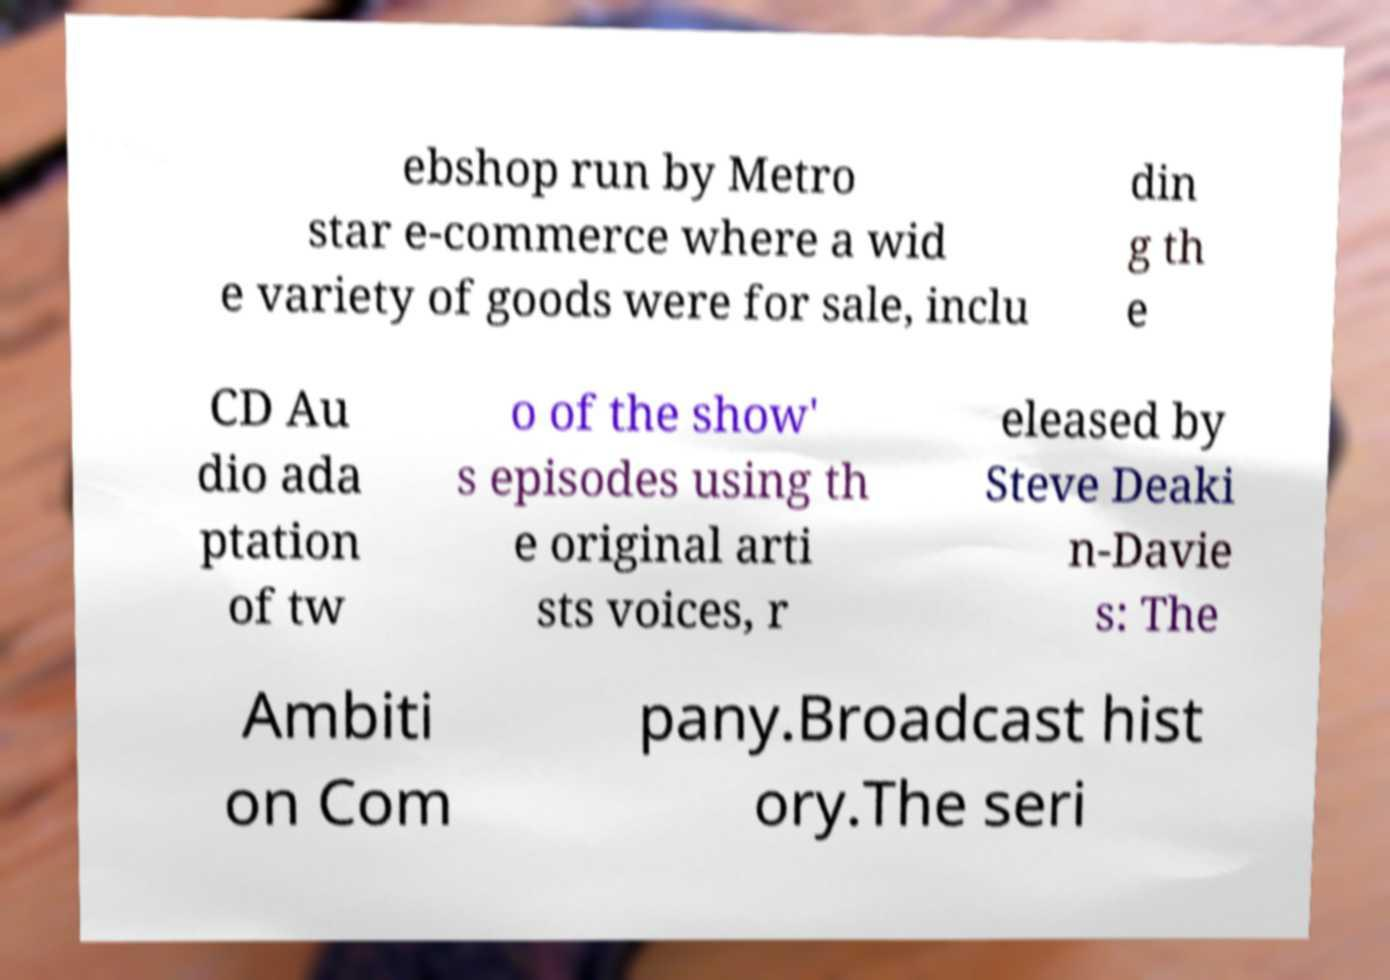I need the written content from this picture converted into text. Can you do that? ebshop run by Metro star e-commerce where a wid e variety of goods were for sale, inclu din g th e CD Au dio ada ptation of tw o of the show' s episodes using th e original arti sts voices, r eleased by Steve Deaki n-Davie s: The Ambiti on Com pany.Broadcast hist ory.The seri 